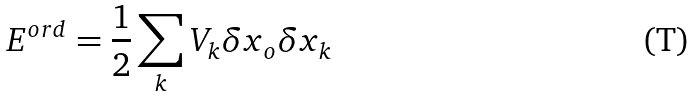<formula> <loc_0><loc_0><loc_500><loc_500>E ^ { o r d } = \frac { 1 } { 2 } \sum _ { k } V _ { k } \delta x _ { o } \delta x _ { k }</formula> 